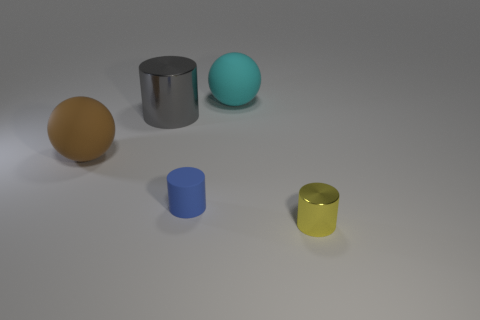Add 2 green matte cylinders. How many objects exist? 7 Subtract all yellow metallic cylinders. How many cylinders are left? 2 Add 3 gray cylinders. How many gray cylinders exist? 4 Subtract all brown balls. How many balls are left? 1 Subtract 0 red spheres. How many objects are left? 5 Subtract all cylinders. How many objects are left? 2 Subtract 1 balls. How many balls are left? 1 Subtract all red cylinders. Subtract all red cubes. How many cylinders are left? 3 Subtract all purple balls. How many purple cylinders are left? 0 Subtract all large balls. Subtract all rubber objects. How many objects are left? 0 